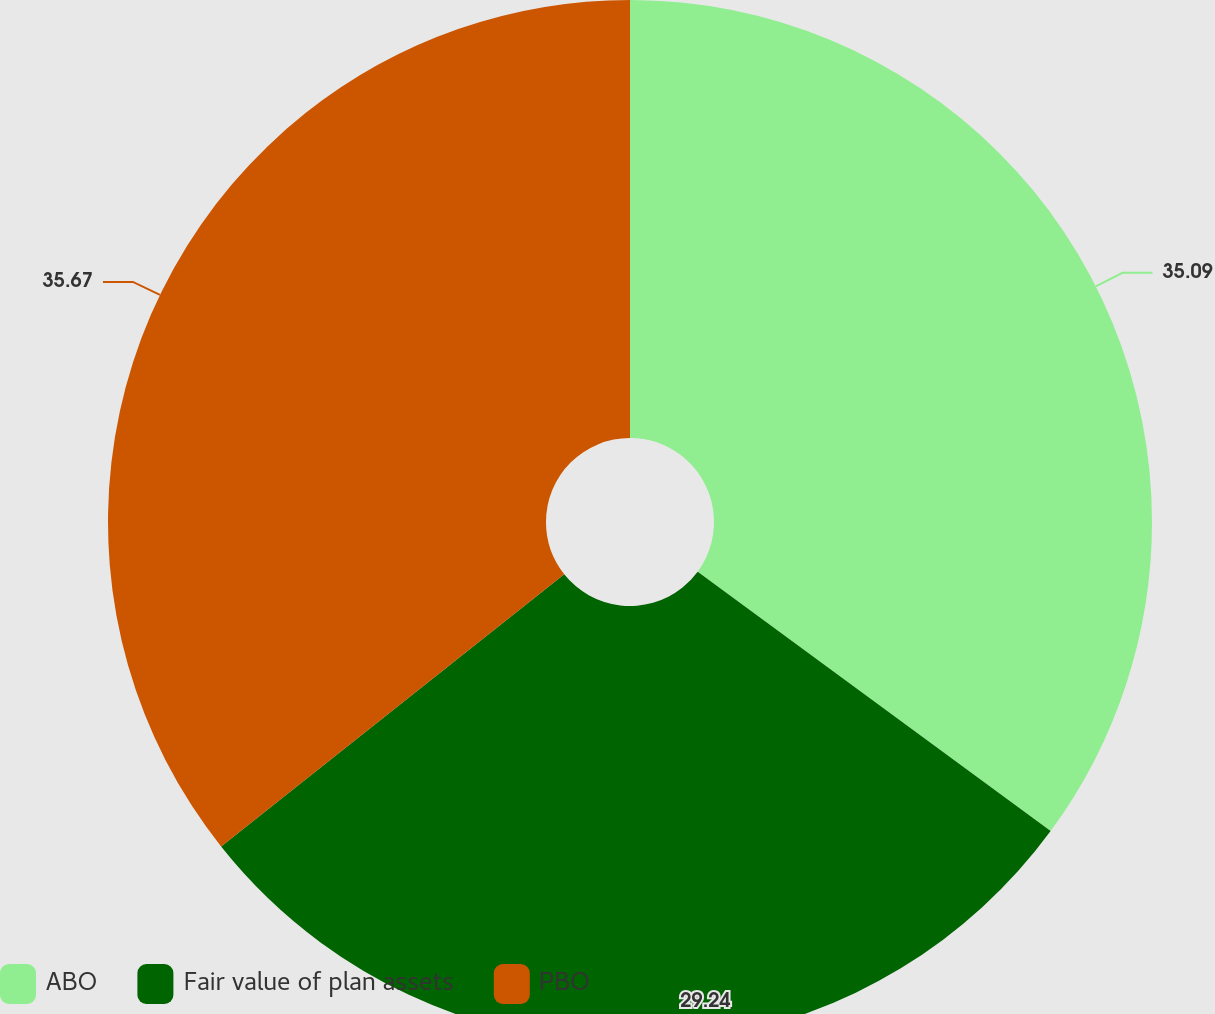Convert chart. <chart><loc_0><loc_0><loc_500><loc_500><pie_chart><fcel>ABO<fcel>Fair value of plan assets<fcel>PBO<nl><fcel>35.09%<fcel>29.24%<fcel>35.68%<nl></chart> 